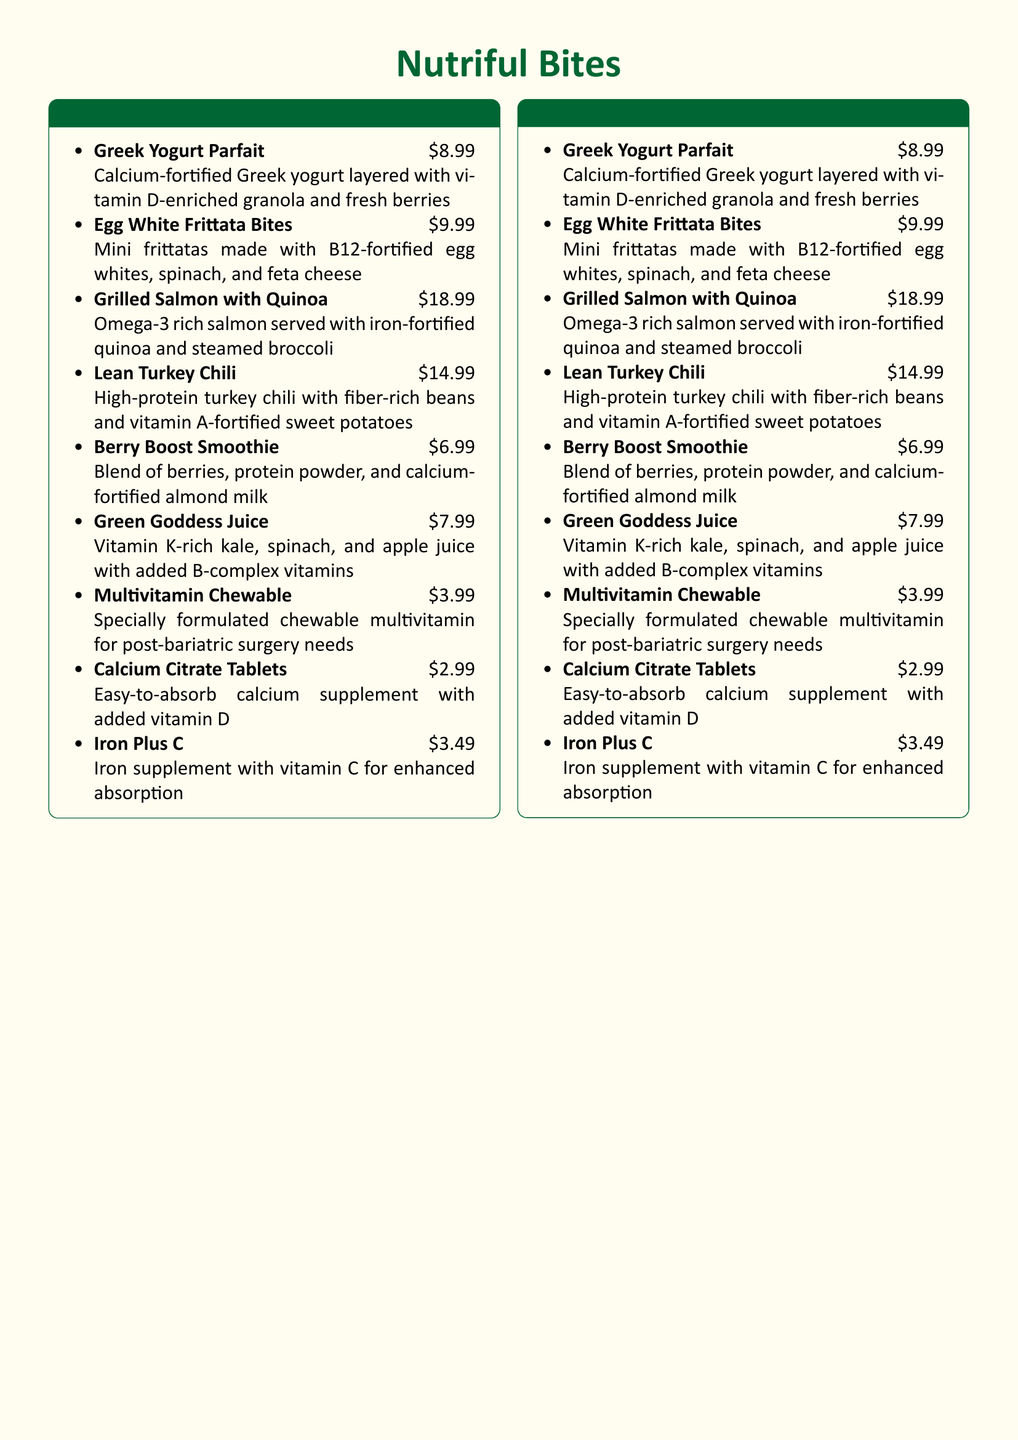What is the name of the restaurant? The restaurant is called "Nutriful Bites".
Answer: Nutriful Bites How much does the Greek Yogurt Parfait cost? The cost listed for the Greek Yogurt Parfait is $8.99.
Answer: $8.99 Which dish is made with egg whites and fortified with B12? The dish made with egg whites and fortified with B12 is the "Egg White Frittata Bites".
Answer: Egg White Frittata Bites What vitamin is enriched in the Berry Boost Smoothie? The Berry Boost Smoothie is enriched with protein powder and calcium-fortified almond milk.
Answer: Calcium How many types of supplements are listed on the menu? There are three types of supplements listed: multivitamin, calcium, and iron.
Answer: Three Which main dish contains omega-3? The main dish that contains omega-3 is "Grilled Salmon with Quinoa".
Answer: Grilled Salmon with Quinoa What kind of beans are used in the Lean Turkey Chili? The Lean Turkey Chili contains fiber-rich beans.
Answer: Fiber-rich beans What is the main focus of the dishes at Nutriful Bites? The main focus of the dishes is to meet post-bariatric surgery dietary guidelines.
Answer: Post-bariatric surgery dietary guidelines What color theme is used in the menu background? The menu background color theme is a soft beige.
Answer: Soft beige What do all dishes adhere to? All dishes adhere to post-bariatric surgery dietary guidelines.
Answer: Dietary guidelines 